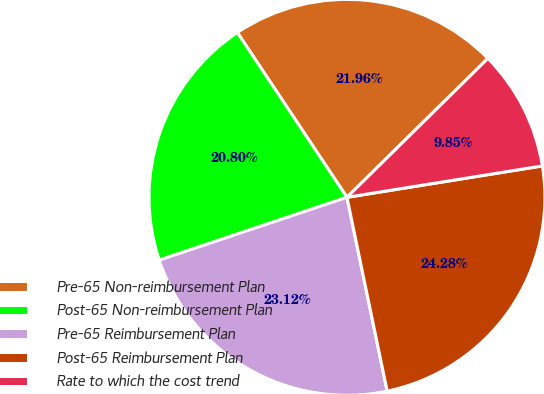Convert chart to OTSL. <chart><loc_0><loc_0><loc_500><loc_500><pie_chart><fcel>Pre-65 Non-reimbursement Plan<fcel>Post-65 Non-reimbursement Plan<fcel>Pre-65 Reimbursement Plan<fcel>Post-65 Reimbursement Plan<fcel>Rate to which the cost trend<nl><fcel>21.96%<fcel>20.8%<fcel>23.12%<fcel>24.28%<fcel>9.85%<nl></chart> 